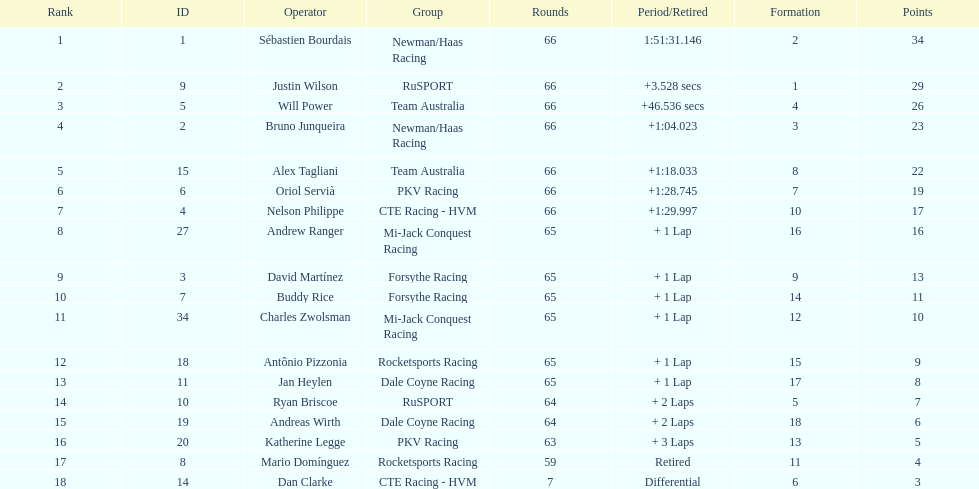At the 2006 gran premio telmex, who finished last? Dan Clarke. Can you parse all the data within this table? {'header': ['Rank', 'ID', 'Operator', 'Group', 'Rounds', 'Period/Retired', 'Formation', 'Points'], 'rows': [['1', '1', 'Sébastien Bourdais', 'Newman/Haas Racing', '66', '1:51:31.146', '2', '34'], ['2', '9', 'Justin Wilson', 'RuSPORT', '66', '+3.528 secs', '1', '29'], ['3', '5', 'Will Power', 'Team Australia', '66', '+46.536 secs', '4', '26'], ['4', '2', 'Bruno Junqueira', 'Newman/Haas Racing', '66', '+1:04.023', '3', '23'], ['5', '15', 'Alex Tagliani', 'Team Australia', '66', '+1:18.033', '8', '22'], ['6', '6', 'Oriol Servià', 'PKV Racing', '66', '+1:28.745', '7', '19'], ['7', '4', 'Nelson Philippe', 'CTE Racing - HVM', '66', '+1:29.997', '10', '17'], ['8', '27', 'Andrew Ranger', 'Mi-Jack Conquest Racing', '65', '+ 1 Lap', '16', '16'], ['9', '3', 'David Martínez', 'Forsythe Racing', '65', '+ 1 Lap', '9', '13'], ['10', '7', 'Buddy Rice', 'Forsythe Racing', '65', '+ 1 Lap', '14', '11'], ['11', '34', 'Charles Zwolsman', 'Mi-Jack Conquest Racing', '65', '+ 1 Lap', '12', '10'], ['12', '18', 'Antônio Pizzonia', 'Rocketsports Racing', '65', '+ 1 Lap', '15', '9'], ['13', '11', 'Jan Heylen', 'Dale Coyne Racing', '65', '+ 1 Lap', '17', '8'], ['14', '10', 'Ryan Briscoe', 'RuSPORT', '64', '+ 2 Laps', '5', '7'], ['15', '19', 'Andreas Wirth', 'Dale Coyne Racing', '64', '+ 2 Laps', '18', '6'], ['16', '20', 'Katherine Legge', 'PKV Racing', '63', '+ 3 Laps', '13', '5'], ['17', '8', 'Mario Domínguez', 'Rocketsports Racing', '59', 'Retired', '11', '4'], ['18', '14', 'Dan Clarke', 'CTE Racing - HVM', '7', 'Differential', '6', '3']]} 